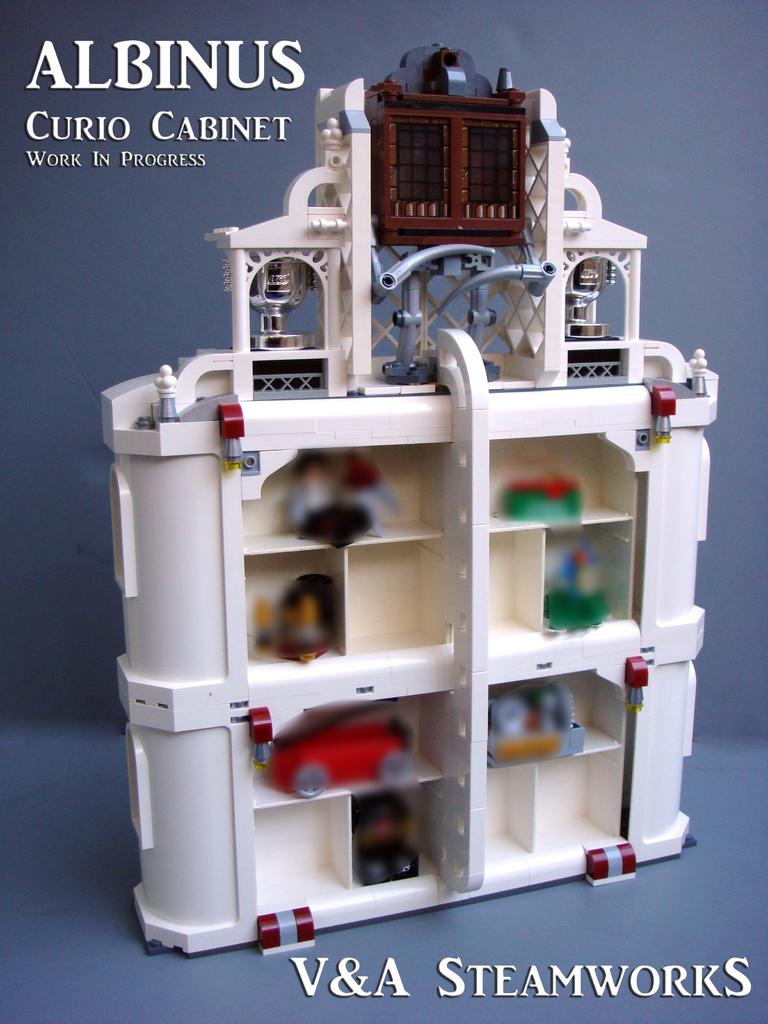What is this a work in?
Your answer should be very brief. Progress. 